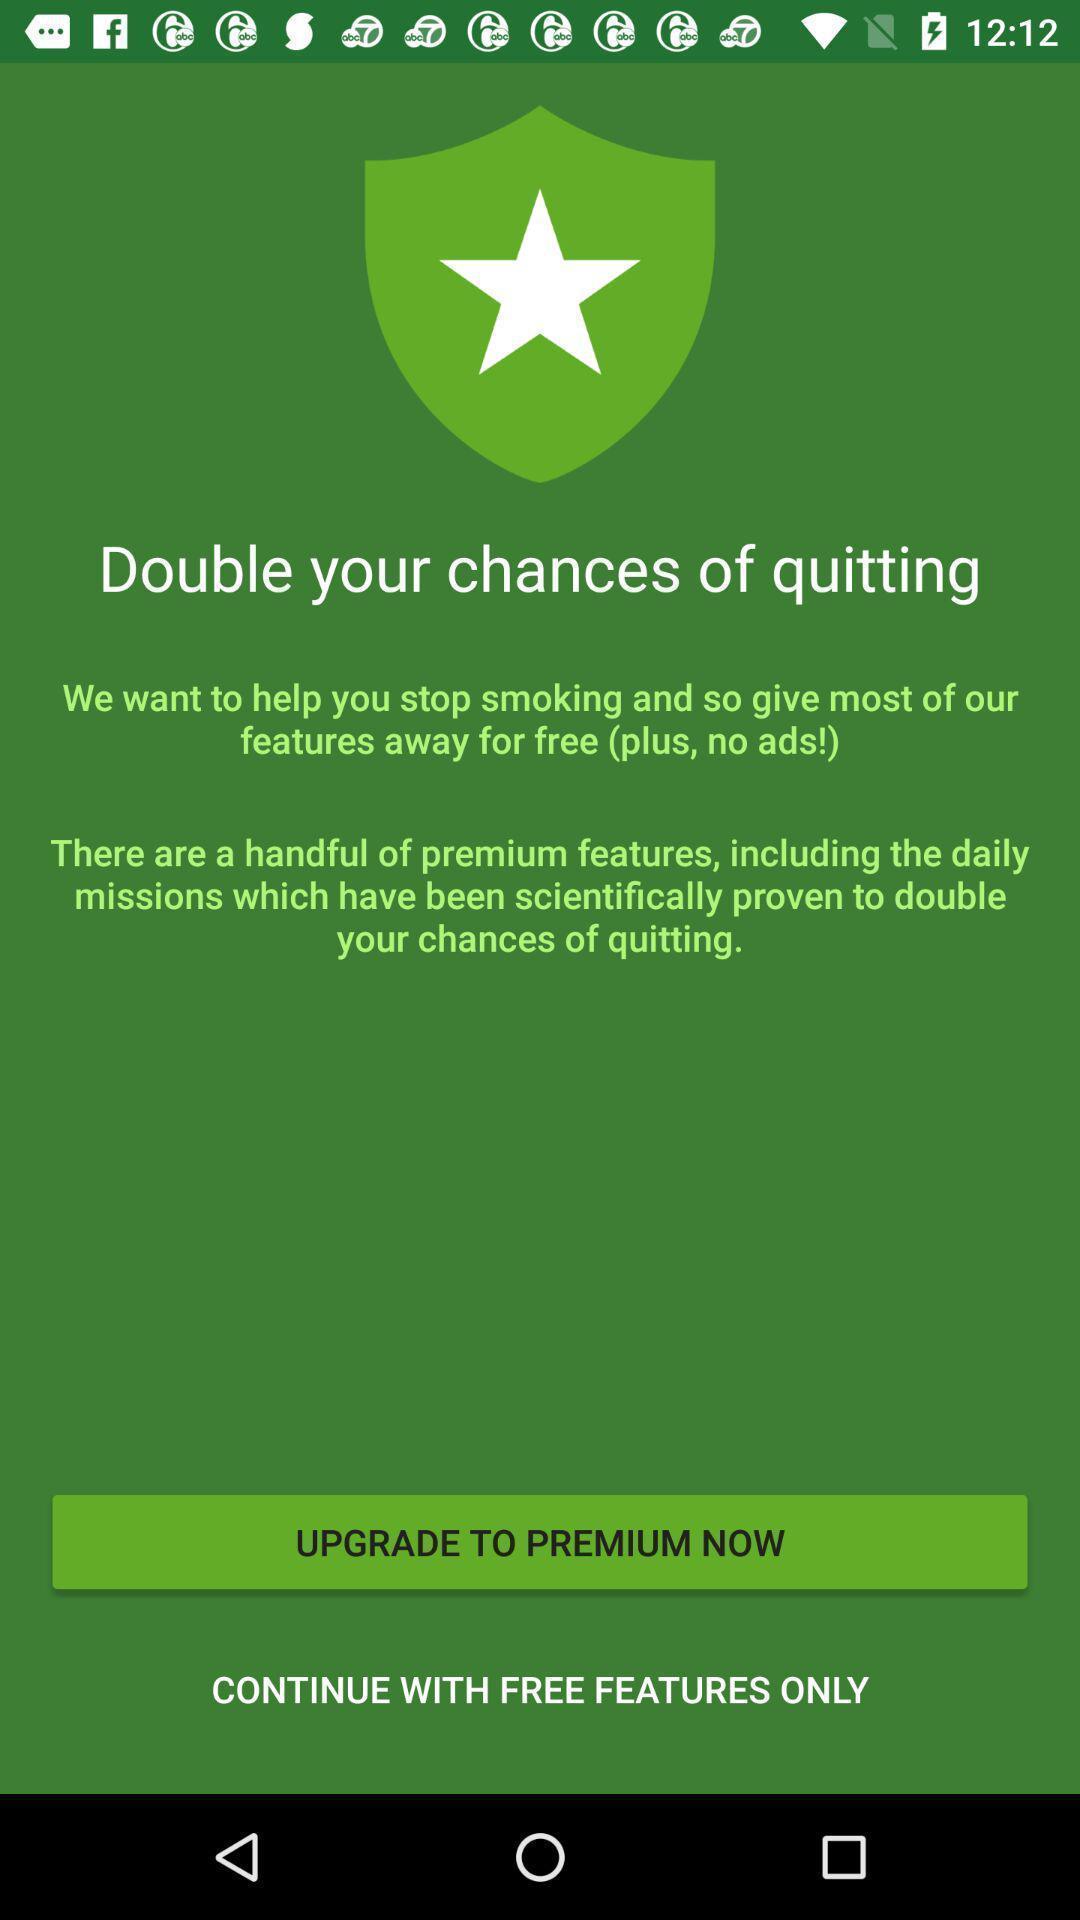Describe this image in words. Welcome page of a smoke quitting app. 